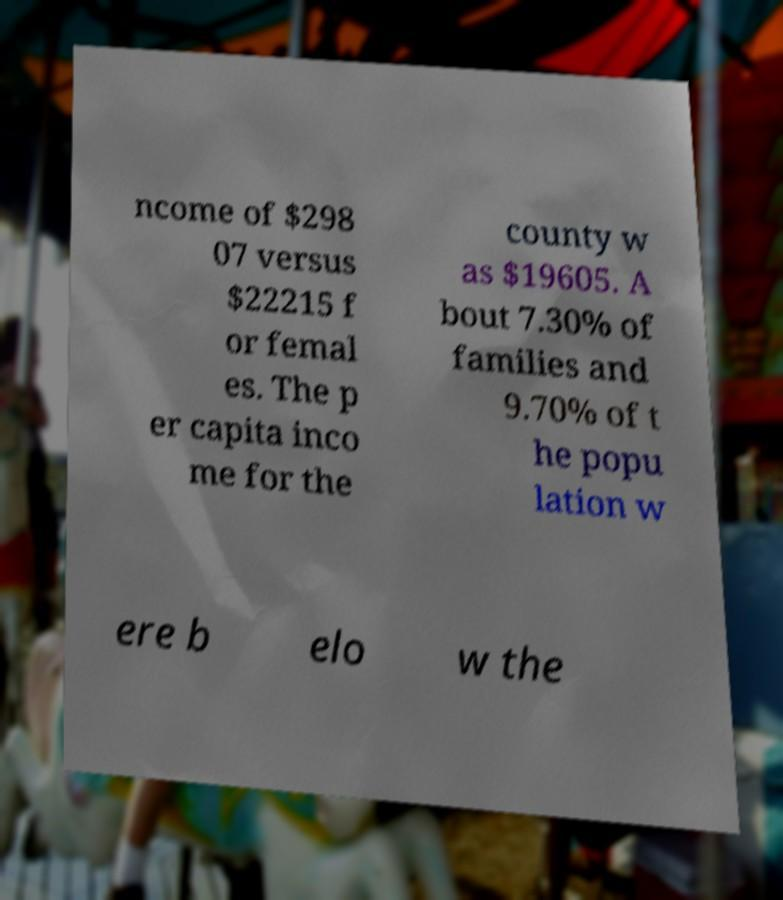What messages or text are displayed in this image? I need them in a readable, typed format. ncome of $298 07 versus $22215 f or femal es. The p er capita inco me for the county w as $19605. A bout 7.30% of families and 9.70% of t he popu lation w ere b elo w the 